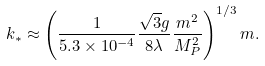Convert formula to latex. <formula><loc_0><loc_0><loc_500><loc_500>k _ { * } \approx \left ( \frac { 1 } { 5 . 3 \times 1 0 ^ { - 4 } } \frac { \sqrt { 3 } g } { 8 \lambda } \frac { m ^ { 2 } } { M _ { P } ^ { 2 } } \right ) ^ { 1 / 3 } m .</formula> 